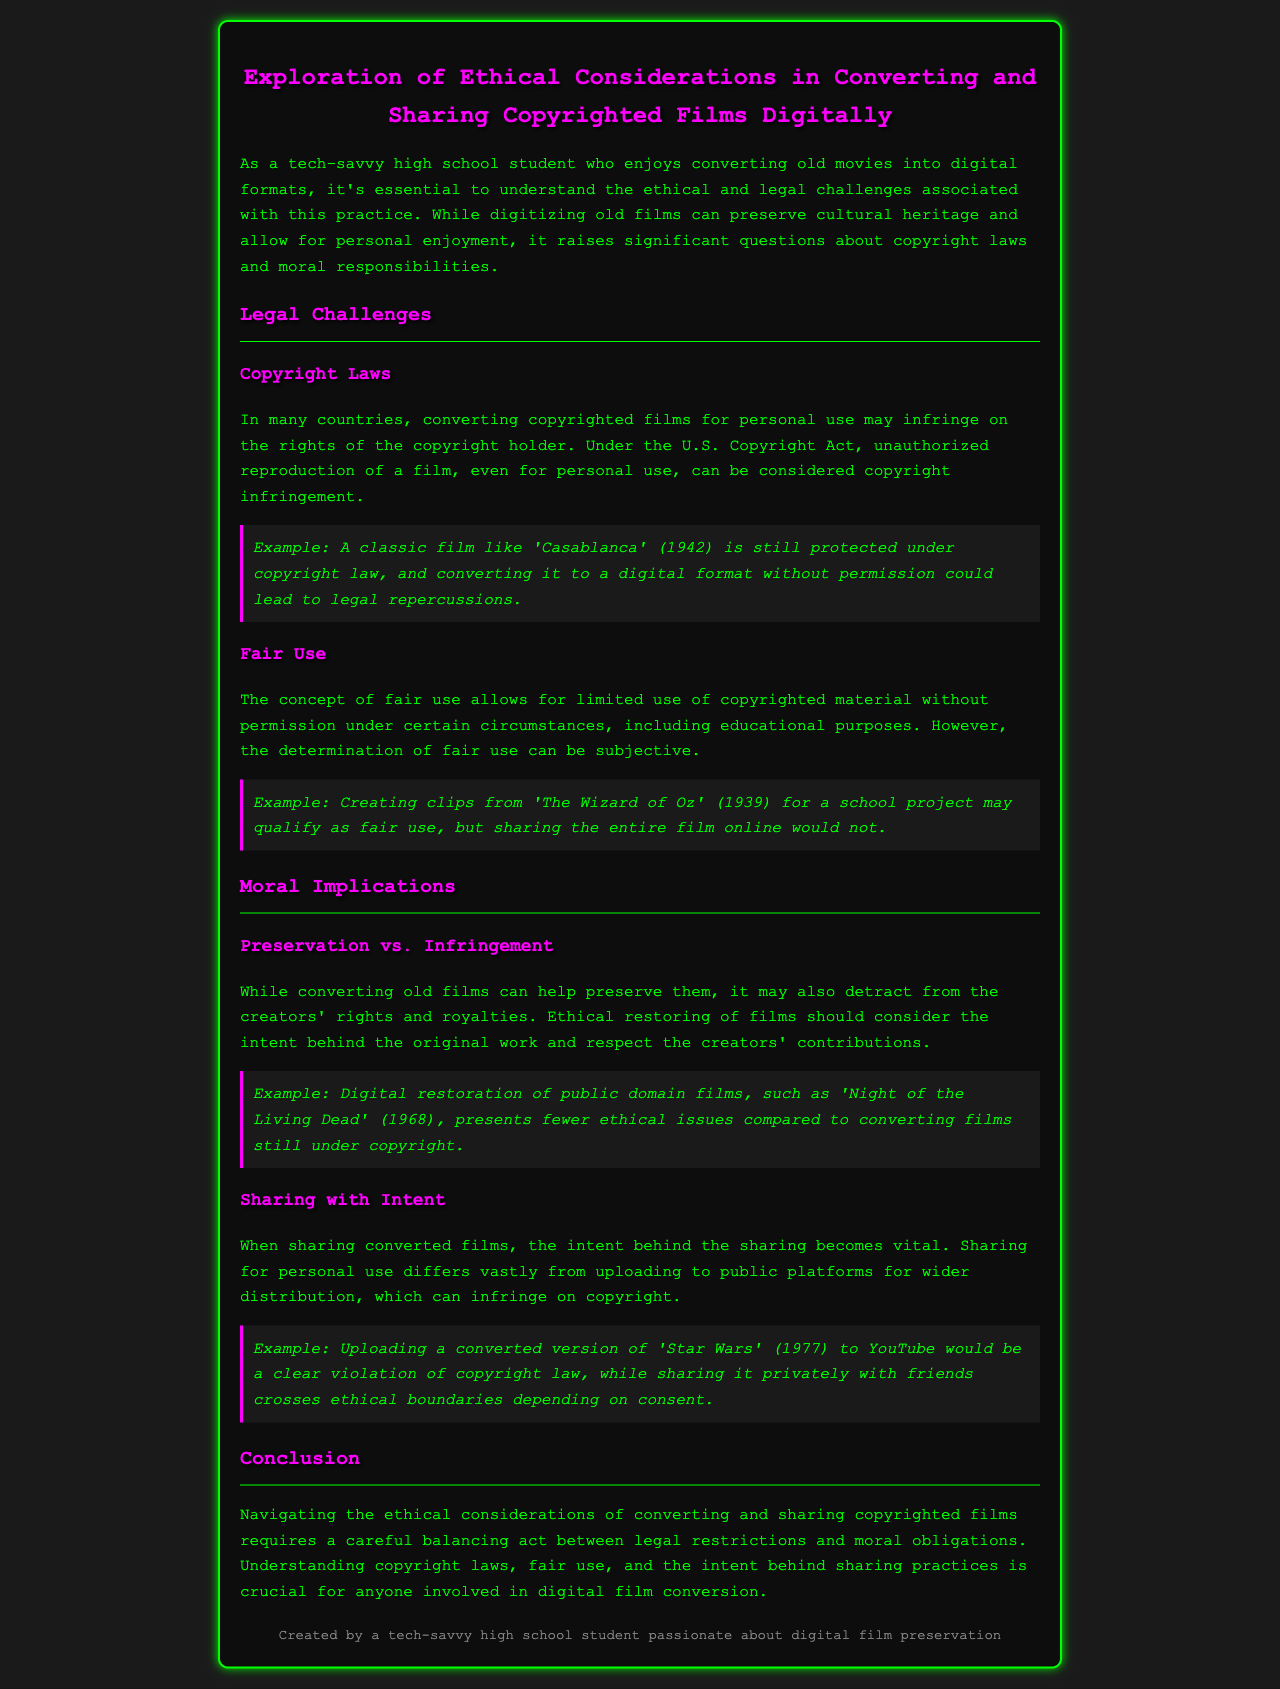What is the title of the report? The title of the report is explicitly mentioned as "Exploration of Ethical Considerations in Converting and Sharing Copyrighted Films Digitally."
Answer: Exploration of Ethical Considerations in Converting and Sharing Copyrighted Films Digitally What year was 'Casablanca' released? The document specifies 'Casablanca' was released in 1942.
Answer: 1942 What is a key legal challenge mentioned in the document? The document highlights copyright laws as a significant legal challenge.
Answer: Copyright laws What concept allows limited use of copyrighted material? The document states that the concept of fair use allows for limited use of copyrighted material without permission.
Answer: Fair use What film is used as an example for fair use regarding a school project? The document mentions 'The Wizard of Oz' (1939) as an example for fair use in a school project.
Answer: The Wizard of Oz Which film is indicated to have fewer ethical issues when restored digitally? The document states that digital restoration of public domain films like 'Night of the Living Dead' (1968) presents fewer ethical issues.
Answer: Night of the Living Dead What stance does the document take on sharing converted films publicly? The document suggests that sharing converted films on public platforms infringes on copyright.
Answer: Infringes on copyright What should one consider when restoring films ethically? The document mentions that one should consider the intent behind the original work when restoring films ethically.
Answer: Intent behind the original work What is essential for anyone involved in digital film conversion? The document states that understanding copyright laws, fair use, and the intent behind sharing practices is crucial.
Answer: Understanding copyright laws, fair use, and intent behind sharing practices 